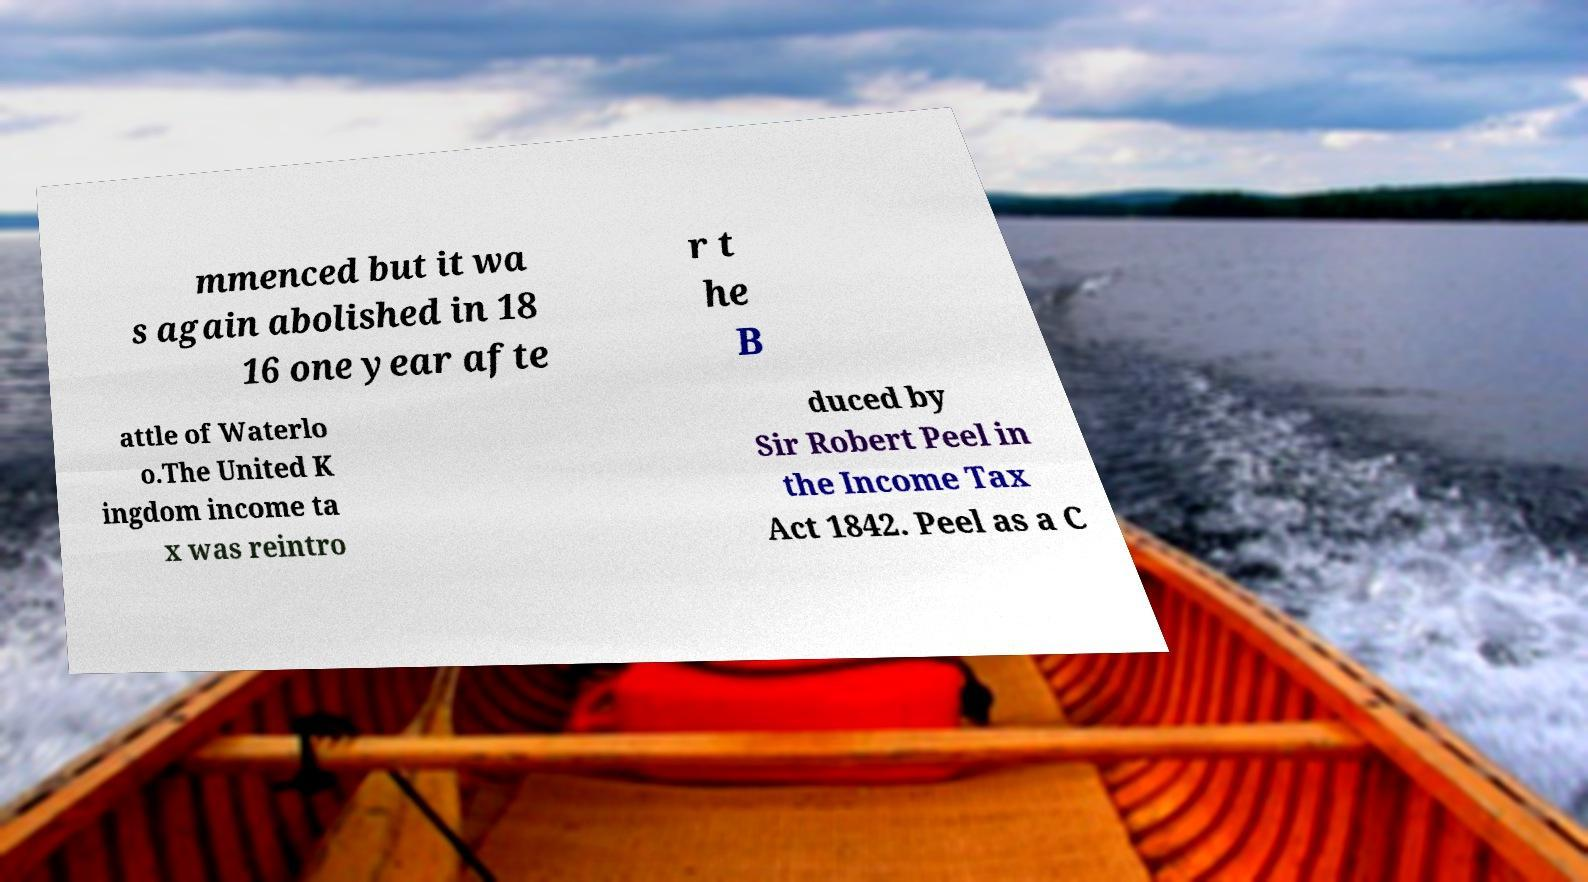Could you extract and type out the text from this image? mmenced but it wa s again abolished in 18 16 one year afte r t he B attle of Waterlo o.The United K ingdom income ta x was reintro duced by Sir Robert Peel in the Income Tax Act 1842. Peel as a C 